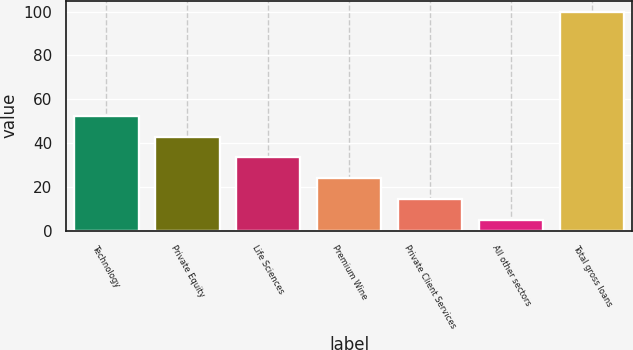Convert chart. <chart><loc_0><loc_0><loc_500><loc_500><bar_chart><fcel>Technology<fcel>Private Equity<fcel>Life Sciences<fcel>Premium Wine<fcel>Private Client Services<fcel>All other sectors<fcel>Total gross loans<nl><fcel>52.4<fcel>42.88<fcel>33.36<fcel>23.84<fcel>14.32<fcel>4.8<fcel>100<nl></chart> 